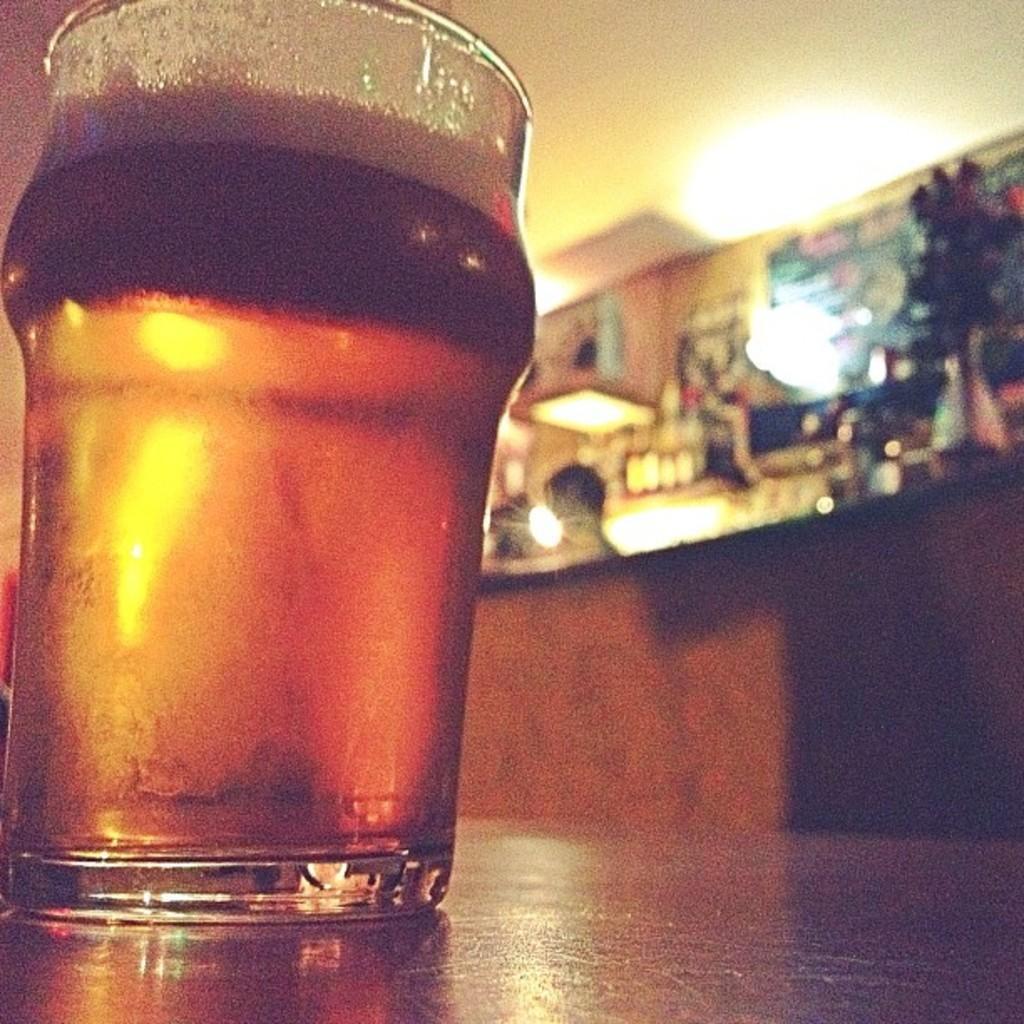Could you give a brief overview of what you see in this image? In this image I can see a glass on the surface. Back I can see a wall,lights,flower pot and few objects on the table. 